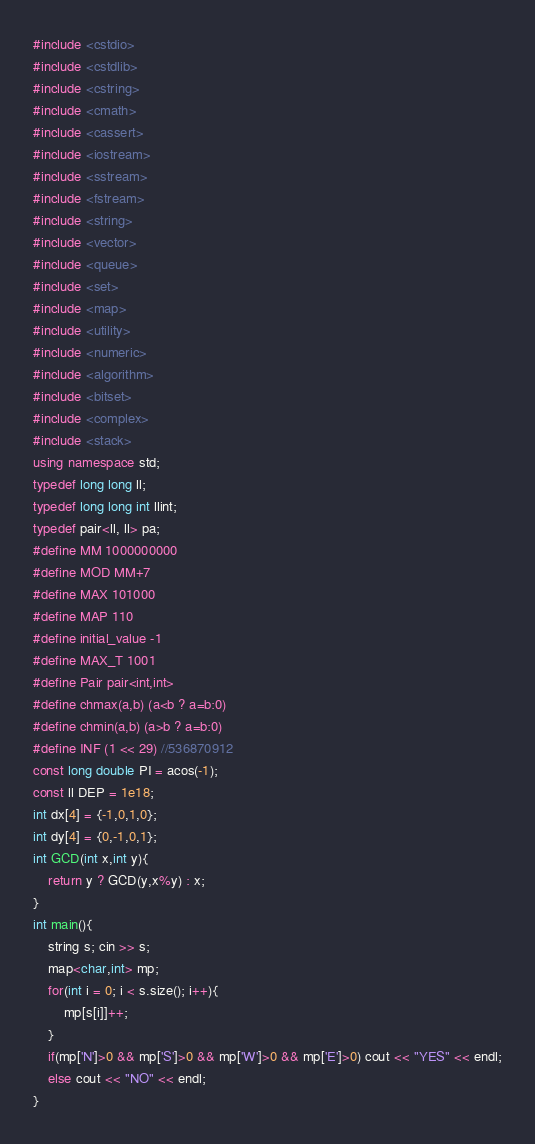<code> <loc_0><loc_0><loc_500><loc_500><_C++_>#include <cstdio>
#include <cstdlib>
#include <cstring>
#include <cmath>
#include <cassert>
#include <iostream>
#include <sstream>
#include <fstream>
#include <string>
#include <vector>
#include <queue>
#include <set>
#include <map>
#include <utility>
#include <numeric>
#include <algorithm>
#include <bitset>
#include <complex>
#include <stack>
using namespace std;
typedef long long ll;
typedef long long int llint;
typedef pair<ll, ll> pa;
#define MM 1000000000
#define MOD MM+7
#define MAX 101000
#define MAP 110
#define initial_value -1
#define MAX_T 1001
#define Pair pair<int,int>
#define chmax(a,b) (a<b ? a=b:0)
#define chmin(a,b) (a>b ? a=b:0)
#define INF (1 << 29) //536870912
const long double PI = acos(-1);
const ll DEP = 1e18;
int dx[4] = {-1,0,1,0};
int dy[4] = {0,-1,0,1};
int GCD(int x,int y){
    return y ? GCD(y,x%y) : x;
}
int main(){
    string s; cin >> s;
    map<char,int> mp;
    for(int i = 0; i < s.size(); i++){
        mp[s[i]]++;
    }
    if(mp['N']>0 && mp['S']>0 && mp['W']>0 && mp['E']>0) cout << "YES" << endl;
    else cout << "NO" << endl;
}

</code> 